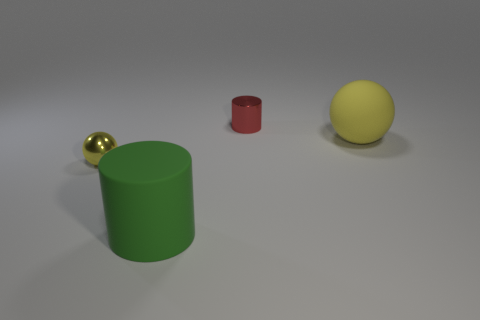Add 2 small spheres. How many objects exist? 6 Add 1 red metal things. How many red metal things are left? 2 Add 3 tiny blue shiny blocks. How many tiny blue shiny blocks exist? 3 Subtract 1 red cylinders. How many objects are left? 3 Subtract all large green spheres. Subtract all big rubber balls. How many objects are left? 3 